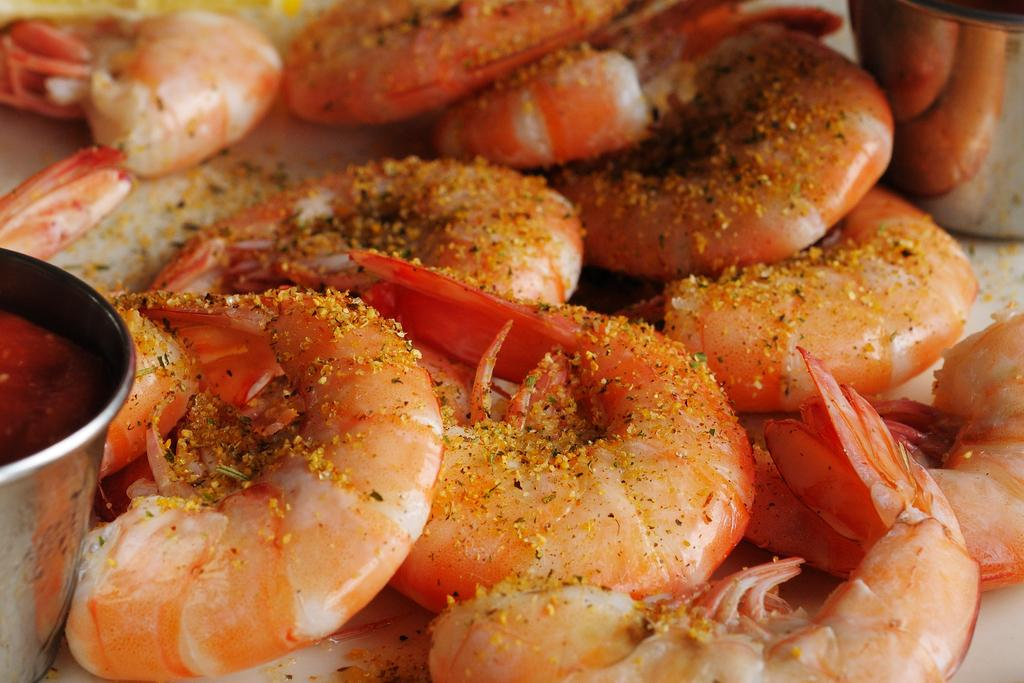What is the focus of the image? The image is zoomed in, with the focus on food items in the center. What type of food can be seen in the image? There are prawns in the image. What are the utensils used for in the image? The utensils contain items, which suggests they are being used to serve or consume the food. What other objects can be seen in the image? There are other objects visible in the image, but their specific details are not mentioned in the provided facts. How many family members are present in the image? There is no mention of family members in the image, as it focuses on food items and utensils. What type of car can be seen in the image? There is no car present in the image; it features food items, utensils, and other objects. 